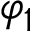Convert formula to latex. <formula><loc_0><loc_0><loc_500><loc_500>\varphi _ { 1 }</formula> 